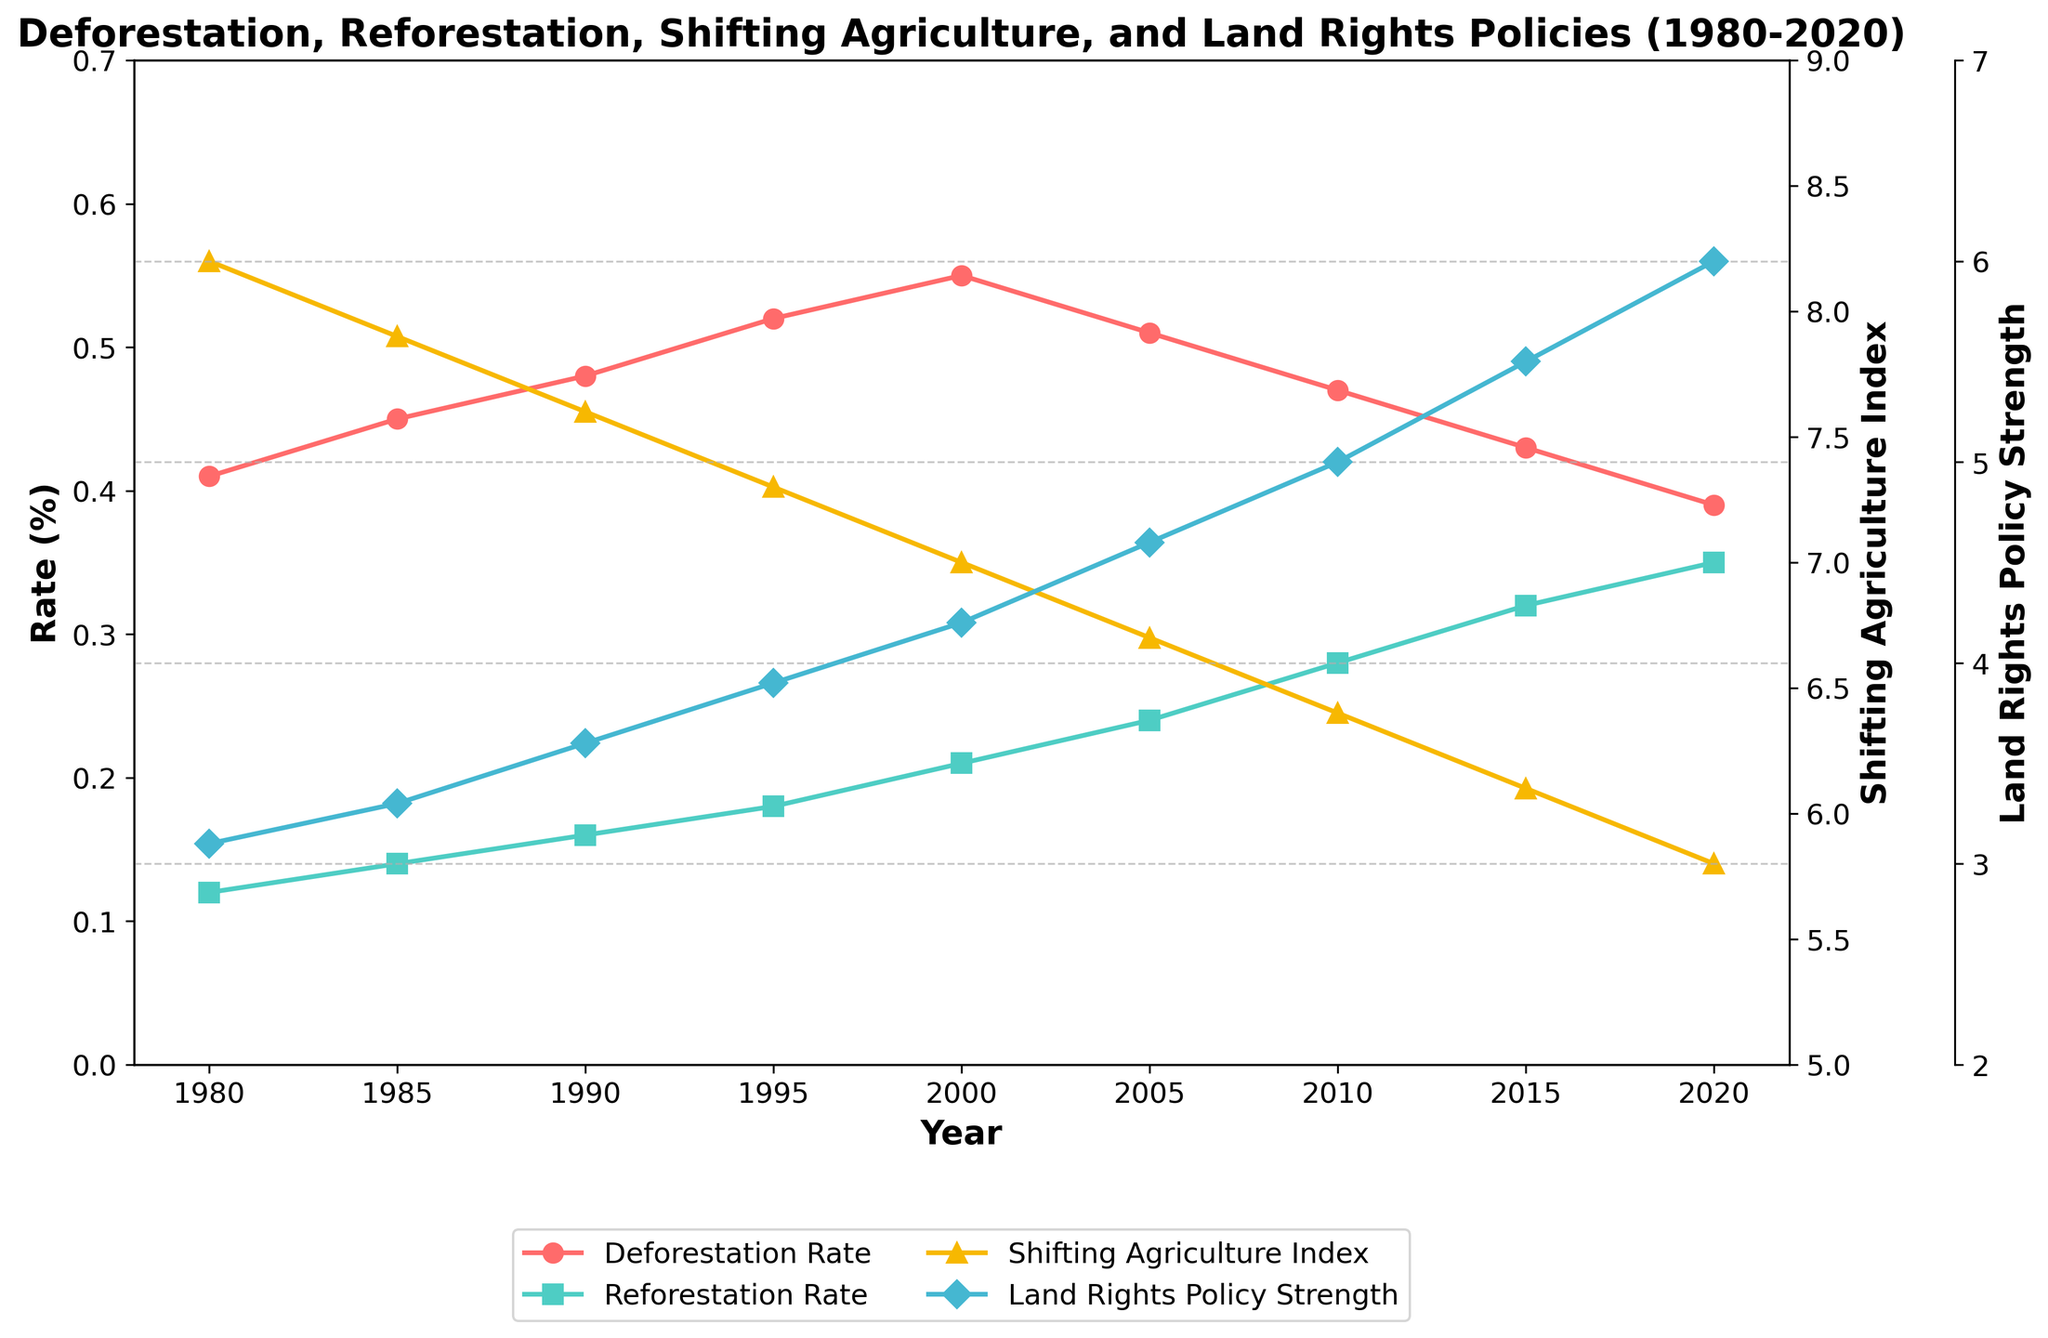What trend can be observed in the Deforestation Rate from 1980 to 2020? The Deforestation Rate increased gradually from 0.41% in 1980 to a peak of 0.55% in 2000, then started to decline, reaching 0.39% in 2020. This indicates a rise until 2000 followed by a steady decrease.
Answer: Declining How does the Reforestation Rate trend differ from the Deforestation Rate trend from 1980 to 2020? The Reforestation Rate showed a continuous increase from 0.12% in 1980 to 0.35% in 2020, in contrast to the Deforestation Rate, which peaked in 2000 and then declined.
Answer: Increasing What relationship can be inferred between the Shifting Agriculture Index and the Deforestation Rate? As the Shifting Agriculture Index decreases from 8.2 in 1980 to 5.8 in 2020, the Deforestation Rate initially increases until 2000 and later decreases. This suggests an inverse relationship where decreases in the Shifting Agriculture Index can lead to changes in the Deforestation Rate.
Answer: Inverse relationship Compare the Land Rights Policy Strength in 2000 and 2020. What difference can you observe? In 2000, the Land Rights Policy Strength was 4.2, while in 2020, it increased to 6.0. The policy strength had a significant increase of 1.8 units over these two decades.
Answer: Increased by 1.8 units What year did the Reforestation Rate first surpass 0.20%, and how does this compare to the trend in the Deforestation Rate at that time? The Reforestation Rate surpassed 0.20% in the year 2000. During this period, the Deforestation Rate was at its peak of 0.55% before it started to decline.
Answer: Year 2000; Deforestation Rate was at its peak Which year observed the highest Shifting Agriculture Index, and what were the Deforestation and Reforestation Rates in that year? The highest Shifting Agriculture Index was 8.2 in the year 1980. In this year, the Deforestation Rate was 0.41%, and the Reforestation Rate was 0.12%.
Answer: 1980; 0.41% and 0.12% Compare the Deforestation Rate and the Land Rights Policy Strength in both 1990 and 2015. In 1990, the Deforestation Rate was 0.48%, and the Land Rights Policy Strength was 3.6. In 2015, the Deforestation Rate decreased to 0.43%, while the Land Rights Policy Strength increased to 5.5.
Answer: Lower Deforestation Rate and higher Land Rights Policy Strength in 2015 Describe the trend of the Reforestation Rate from 1995 to 2010 and support it with numerical values. The Reforestation Rate showed a consistent increase from 0.18% in 1995 to 0.28% in 2010. This represents a gradual rise of 0.10 percentage points over the 15-year period.
Answer: Increasing from 0.18% to 0.28% What can be inferred from the convergence of the Reforestation Rate and the rising Land Rights Policy Strength since 2000? Since 2000, as Land Rights Policy Strength increased from 4.2 to 6.0 in 2020, the Reforestation Rate also rose significantly from 0.21% to 0.35%. This indicates a potential positive correlation where stronger land rights policies may support reforestation efforts.
Answer: Positive correlation 